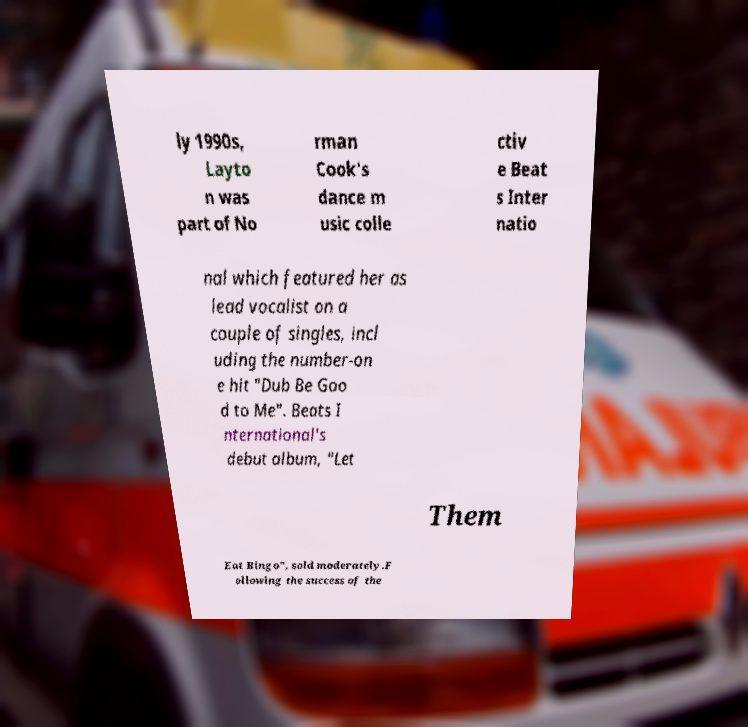Please identify and transcribe the text found in this image. ly 1990s, Layto n was part of No rman Cook's dance m usic colle ctiv e Beat s Inter natio nal which featured her as lead vocalist on a couple of singles, incl uding the number-on e hit "Dub Be Goo d to Me". Beats I nternational's debut album, "Let Them Eat Bingo", sold moderately.F ollowing the success of the 